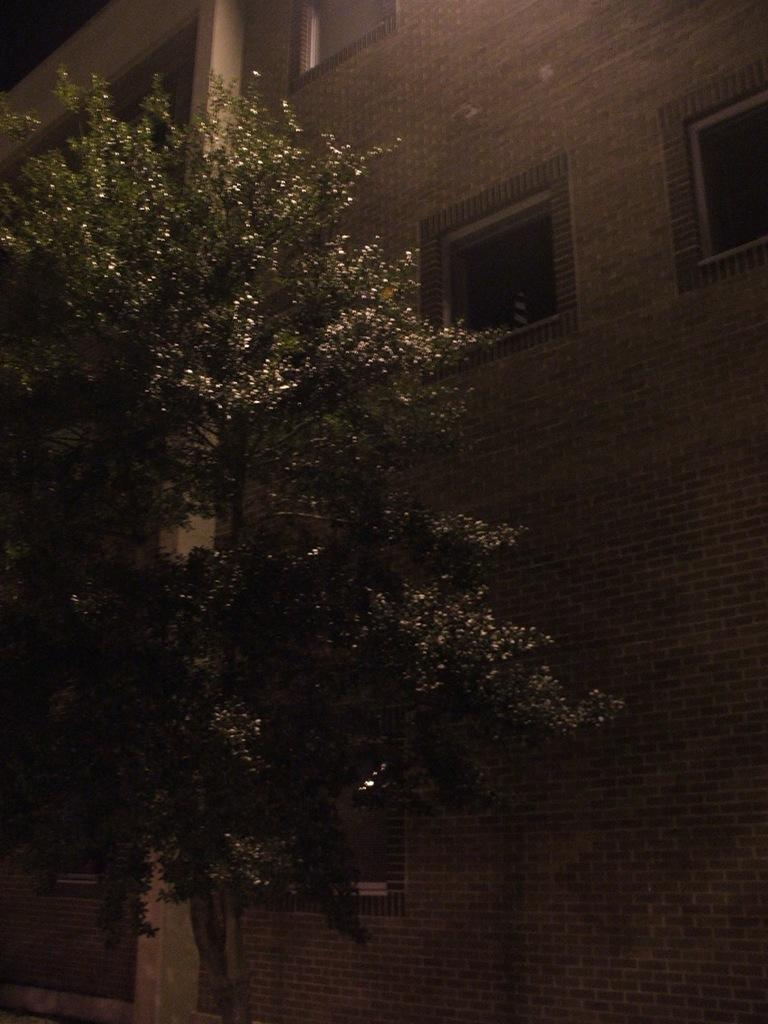What is the main object in the foreground of the image? There is a tree in the image. What can be seen behind the tree? There is a building behind the tree. What feature of the building is mentioned in the facts? The building has windows. Is there a mask hanging on the tree in the image? There is no mention of a mask in the facts provided, so we cannot determine if there is a mask hanging on the tree in the image. 